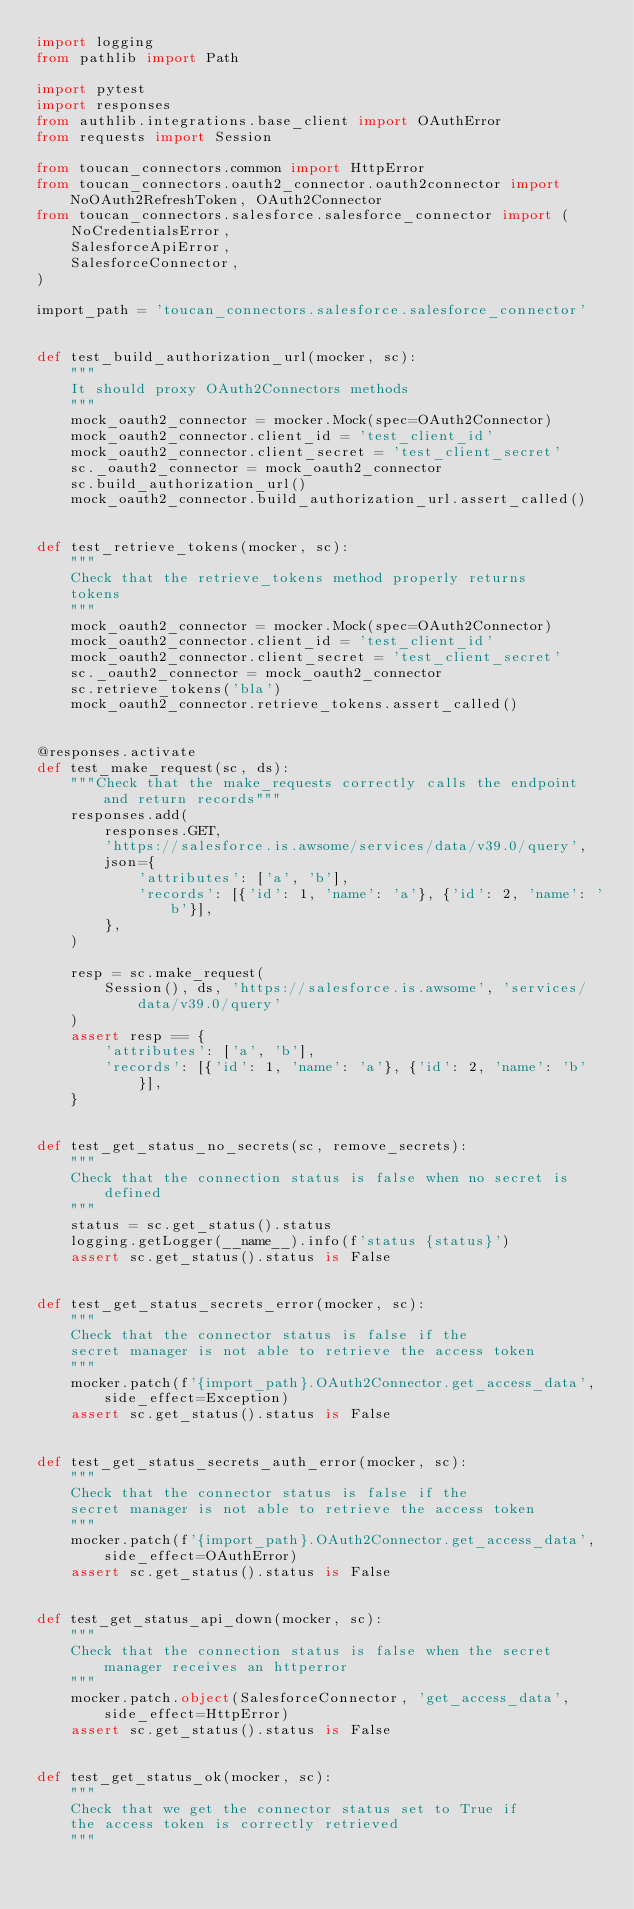<code> <loc_0><loc_0><loc_500><loc_500><_Python_>import logging
from pathlib import Path

import pytest
import responses
from authlib.integrations.base_client import OAuthError
from requests import Session

from toucan_connectors.common import HttpError
from toucan_connectors.oauth2_connector.oauth2connector import NoOAuth2RefreshToken, OAuth2Connector
from toucan_connectors.salesforce.salesforce_connector import (
    NoCredentialsError,
    SalesforceApiError,
    SalesforceConnector,
)

import_path = 'toucan_connectors.salesforce.salesforce_connector'


def test_build_authorization_url(mocker, sc):
    """
    It should proxy OAuth2Connectors methods
    """
    mock_oauth2_connector = mocker.Mock(spec=OAuth2Connector)
    mock_oauth2_connector.client_id = 'test_client_id'
    mock_oauth2_connector.client_secret = 'test_client_secret'
    sc._oauth2_connector = mock_oauth2_connector
    sc.build_authorization_url()
    mock_oauth2_connector.build_authorization_url.assert_called()


def test_retrieve_tokens(mocker, sc):
    """
    Check that the retrieve_tokens method properly returns
    tokens
    """
    mock_oauth2_connector = mocker.Mock(spec=OAuth2Connector)
    mock_oauth2_connector.client_id = 'test_client_id'
    mock_oauth2_connector.client_secret = 'test_client_secret'
    sc._oauth2_connector = mock_oauth2_connector
    sc.retrieve_tokens('bla')
    mock_oauth2_connector.retrieve_tokens.assert_called()


@responses.activate
def test_make_request(sc, ds):
    """Check that the make_requests correctly calls the endpoint and return records"""
    responses.add(
        responses.GET,
        'https://salesforce.is.awsome/services/data/v39.0/query',
        json={
            'attributes': ['a', 'b'],
            'records': [{'id': 1, 'name': 'a'}, {'id': 2, 'name': 'b'}],
        },
    )

    resp = sc.make_request(
        Session(), ds, 'https://salesforce.is.awsome', 'services/data/v39.0/query'
    )
    assert resp == {
        'attributes': ['a', 'b'],
        'records': [{'id': 1, 'name': 'a'}, {'id': 2, 'name': 'b'}],
    }


def test_get_status_no_secrets(sc, remove_secrets):
    """
    Check that the connection status is false when no secret is defined
    """
    status = sc.get_status().status
    logging.getLogger(__name__).info(f'status {status}')
    assert sc.get_status().status is False


def test_get_status_secrets_error(mocker, sc):
    """
    Check that the connector status is false if the
    secret manager is not able to retrieve the access token
    """
    mocker.patch(f'{import_path}.OAuth2Connector.get_access_data', side_effect=Exception)
    assert sc.get_status().status is False


def test_get_status_secrets_auth_error(mocker, sc):
    """
    Check that the connector status is false if the
    secret manager is not able to retrieve the access token
    """
    mocker.patch(f'{import_path}.OAuth2Connector.get_access_data', side_effect=OAuthError)
    assert sc.get_status().status is False


def test_get_status_api_down(mocker, sc):
    """
    Check that the connection status is false when the secret manager receives an httperror
    """
    mocker.patch.object(SalesforceConnector, 'get_access_data', side_effect=HttpError)
    assert sc.get_status().status is False


def test_get_status_ok(mocker, sc):
    """
    Check that we get the connector status set to True if
    the access token is correctly retrieved
    """</code> 